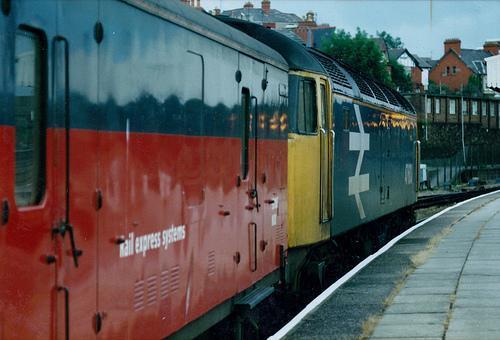How many trains are visible?
Give a very brief answer. 1. How many train cars are visible?
Give a very brief answer. 2. How many trains are red and black?
Give a very brief answer. 1. 